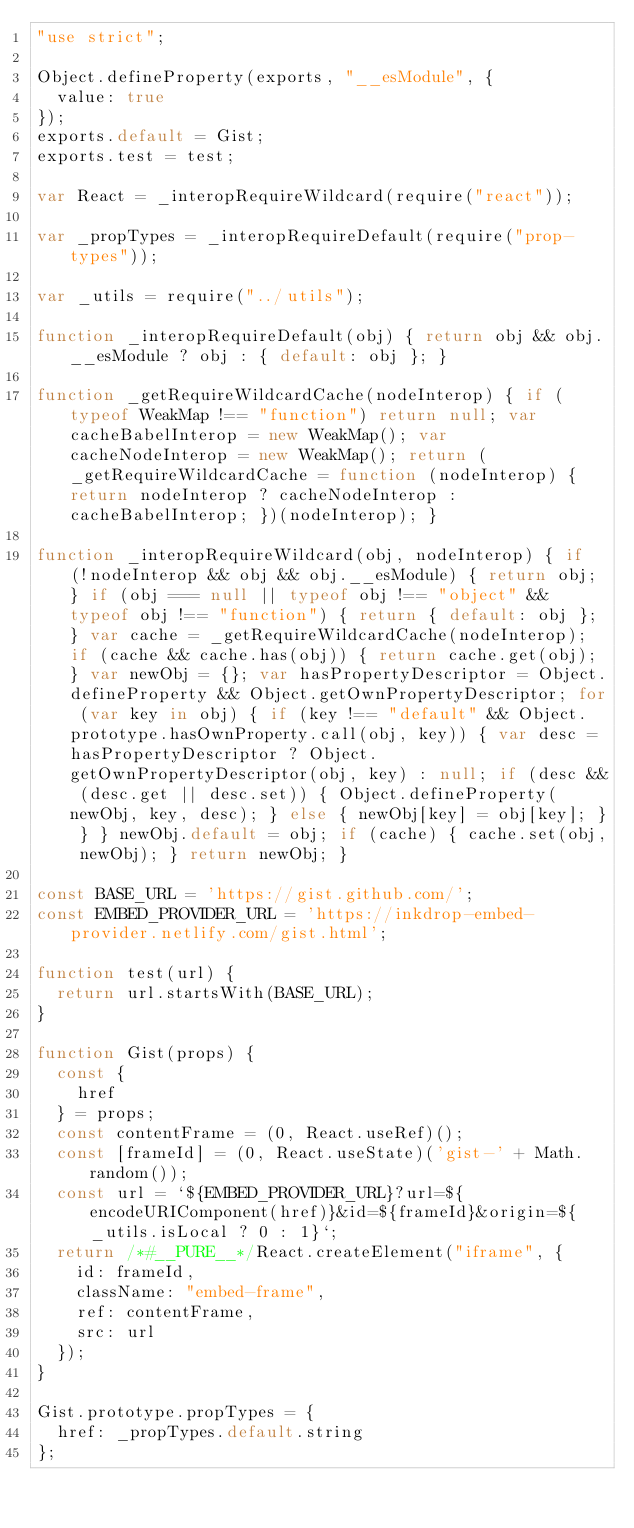Convert code to text. <code><loc_0><loc_0><loc_500><loc_500><_JavaScript_>"use strict";

Object.defineProperty(exports, "__esModule", {
  value: true
});
exports.default = Gist;
exports.test = test;

var React = _interopRequireWildcard(require("react"));

var _propTypes = _interopRequireDefault(require("prop-types"));

var _utils = require("../utils");

function _interopRequireDefault(obj) { return obj && obj.__esModule ? obj : { default: obj }; }

function _getRequireWildcardCache(nodeInterop) { if (typeof WeakMap !== "function") return null; var cacheBabelInterop = new WeakMap(); var cacheNodeInterop = new WeakMap(); return (_getRequireWildcardCache = function (nodeInterop) { return nodeInterop ? cacheNodeInterop : cacheBabelInterop; })(nodeInterop); }

function _interopRequireWildcard(obj, nodeInterop) { if (!nodeInterop && obj && obj.__esModule) { return obj; } if (obj === null || typeof obj !== "object" && typeof obj !== "function") { return { default: obj }; } var cache = _getRequireWildcardCache(nodeInterop); if (cache && cache.has(obj)) { return cache.get(obj); } var newObj = {}; var hasPropertyDescriptor = Object.defineProperty && Object.getOwnPropertyDescriptor; for (var key in obj) { if (key !== "default" && Object.prototype.hasOwnProperty.call(obj, key)) { var desc = hasPropertyDescriptor ? Object.getOwnPropertyDescriptor(obj, key) : null; if (desc && (desc.get || desc.set)) { Object.defineProperty(newObj, key, desc); } else { newObj[key] = obj[key]; } } } newObj.default = obj; if (cache) { cache.set(obj, newObj); } return newObj; }

const BASE_URL = 'https://gist.github.com/';
const EMBED_PROVIDER_URL = 'https://inkdrop-embed-provider.netlify.com/gist.html';

function test(url) {
  return url.startsWith(BASE_URL);
}

function Gist(props) {
  const {
    href
  } = props;
  const contentFrame = (0, React.useRef)();
  const [frameId] = (0, React.useState)('gist-' + Math.random());
  const url = `${EMBED_PROVIDER_URL}?url=${encodeURIComponent(href)}&id=${frameId}&origin=${_utils.isLocal ? 0 : 1}`;
  return /*#__PURE__*/React.createElement("iframe", {
    id: frameId,
    className: "embed-frame",
    ref: contentFrame,
    src: url
  });
}

Gist.prototype.propTypes = {
  href: _propTypes.default.string
};</code> 